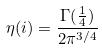Convert formula to latex. <formula><loc_0><loc_0><loc_500><loc_500>\eta ( i ) = \frac { \Gamma ( \frac { 1 } { 4 } ) } { 2 \pi ^ { 3 / 4 } }</formula> 